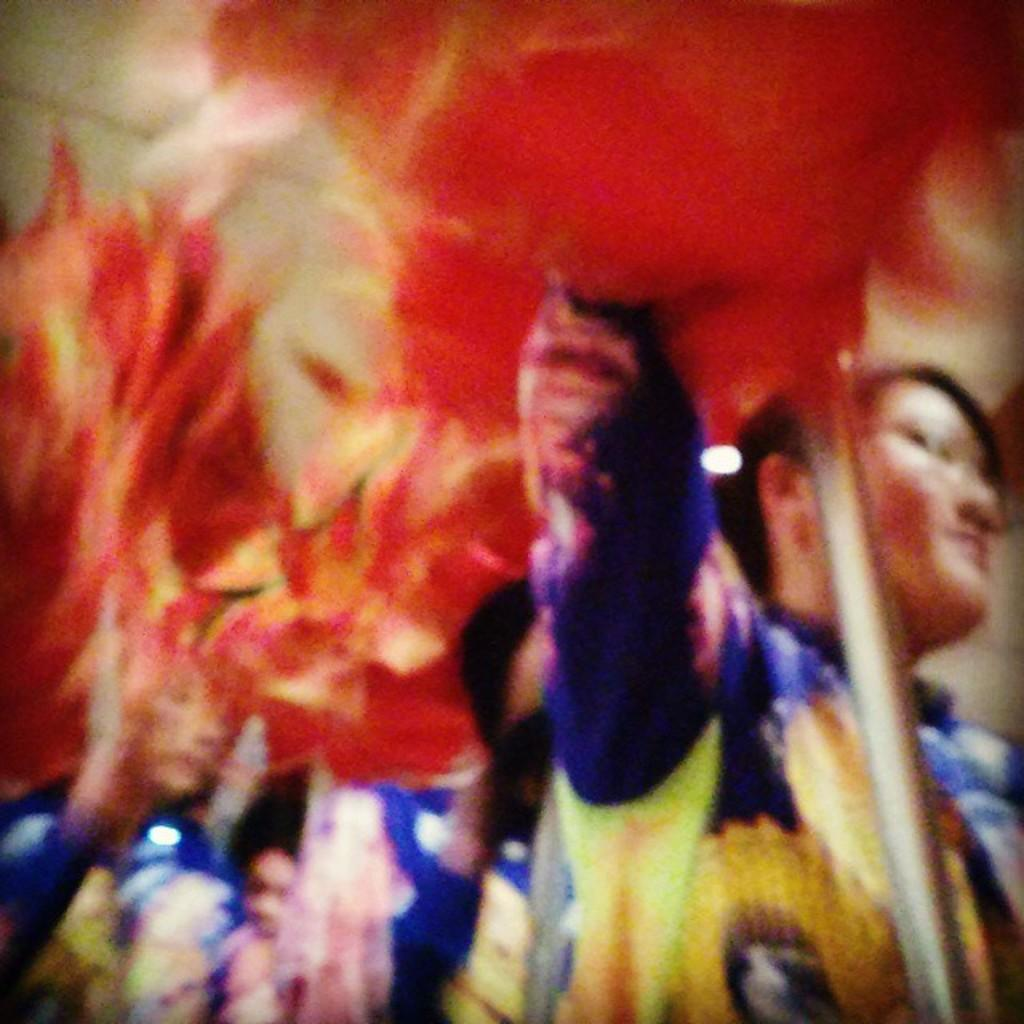Who is present in the image? There are women in the image. What are the women holding in their hands? The women are holding something in their hands. What can be said about the color of the objects they are holding? The objects they are holding are red in color. What type of fruit can be seen growing in the field in the image? There is no field or fruit present in the image; it features women holding red objects. 